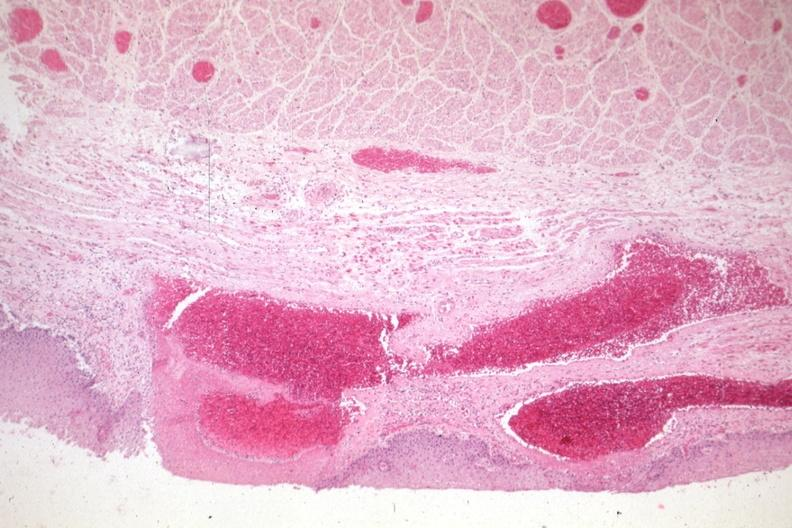does this image show good example of varices?
Answer the question using a single word or phrase. Yes 